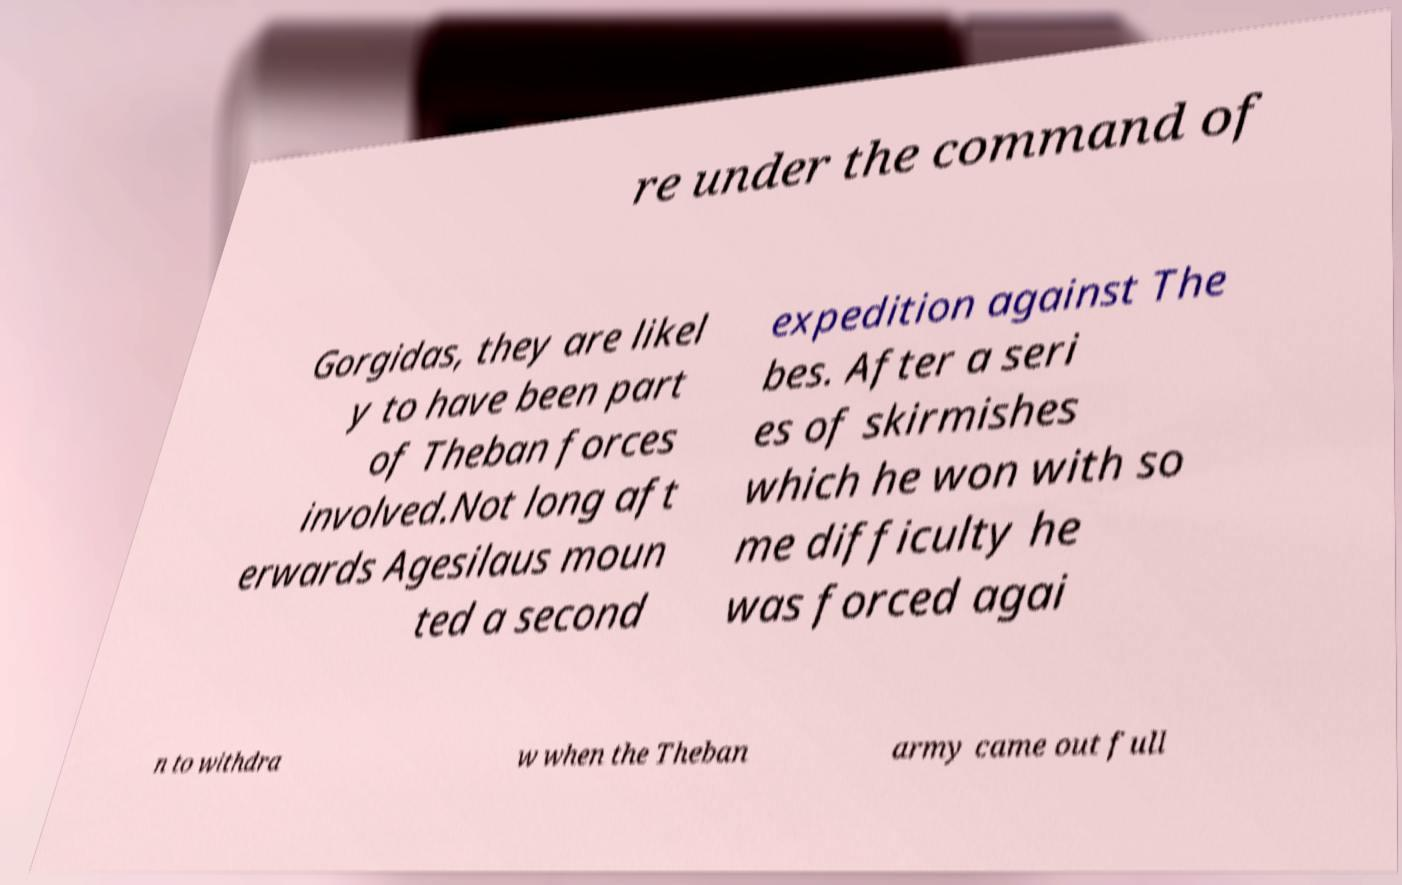There's text embedded in this image that I need extracted. Can you transcribe it verbatim? re under the command of Gorgidas, they are likel y to have been part of Theban forces involved.Not long aft erwards Agesilaus moun ted a second expedition against The bes. After a seri es of skirmishes which he won with so me difficulty he was forced agai n to withdra w when the Theban army came out full 